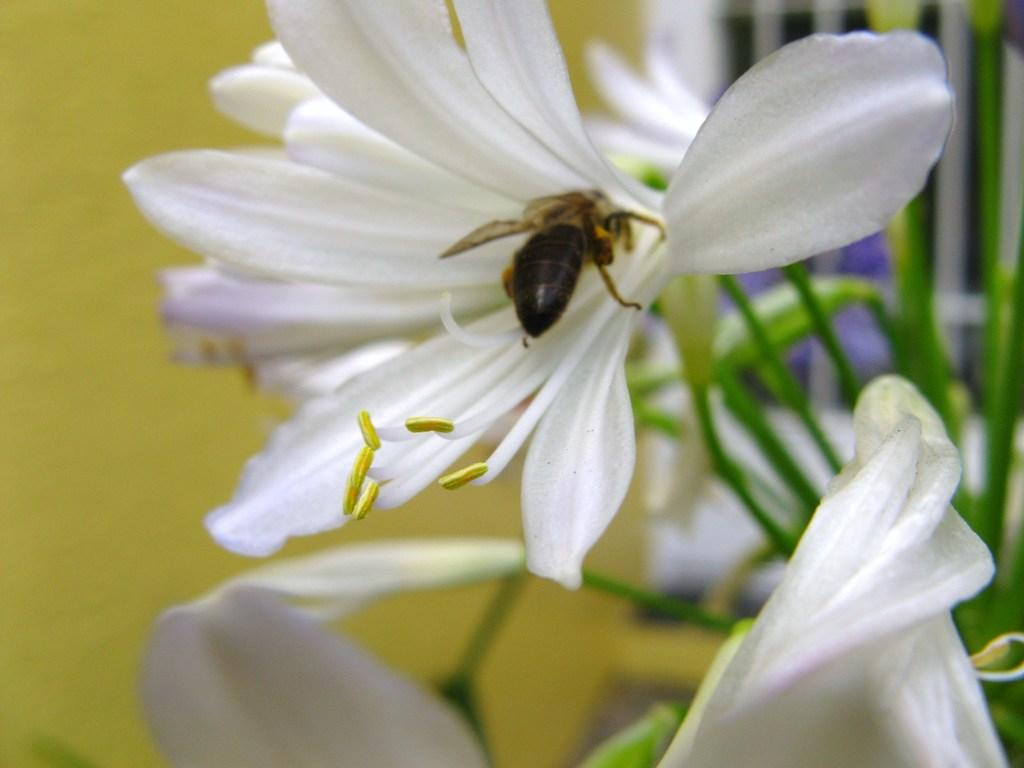What is present in the image? There is a bee in the image. Where is the bee located? The bee is on a flower. What type of office equipment can be seen in the image? There is no office equipment present in the image; it features a bee on a flower. What is the bee singing in the image? Bees do not sing songs, so there is no song being sung by the bee in the image. 